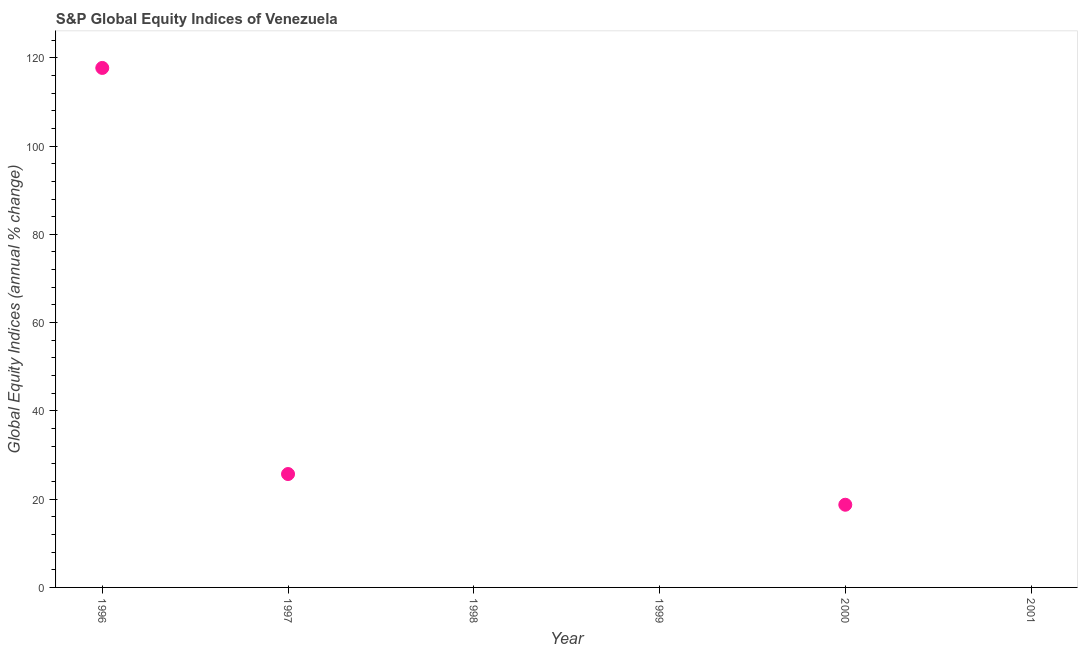Across all years, what is the maximum s&p global equity indices?
Your response must be concise. 117.7. Across all years, what is the minimum s&p global equity indices?
Make the answer very short. 0. What is the sum of the s&p global equity indices?
Give a very brief answer. 162.13. What is the difference between the s&p global equity indices in 1996 and 2000?
Give a very brief answer. 98.96. What is the average s&p global equity indices per year?
Offer a very short reply. 27.02. What is the median s&p global equity indices?
Give a very brief answer. 9.37. What is the ratio of the s&p global equity indices in 1997 to that in 2000?
Make the answer very short. 1.37. Is the difference between the s&p global equity indices in 1996 and 1997 greater than the difference between any two years?
Offer a terse response. No. What is the difference between the highest and the second highest s&p global equity indices?
Your response must be concise. 92.01. What is the difference between the highest and the lowest s&p global equity indices?
Offer a very short reply. 117.7. How many years are there in the graph?
Provide a short and direct response. 6. Does the graph contain any zero values?
Your answer should be compact. Yes. What is the title of the graph?
Provide a short and direct response. S&P Global Equity Indices of Venezuela. What is the label or title of the Y-axis?
Keep it short and to the point. Global Equity Indices (annual % change). What is the Global Equity Indices (annual % change) in 1996?
Keep it short and to the point. 117.7. What is the Global Equity Indices (annual % change) in 1997?
Make the answer very short. 25.69. What is the Global Equity Indices (annual % change) in 2000?
Keep it short and to the point. 18.74. What is the Global Equity Indices (annual % change) in 2001?
Your answer should be compact. 0. What is the difference between the Global Equity Indices (annual % change) in 1996 and 1997?
Make the answer very short. 92.01. What is the difference between the Global Equity Indices (annual % change) in 1996 and 2000?
Offer a very short reply. 98.96. What is the difference between the Global Equity Indices (annual % change) in 1997 and 2000?
Your answer should be very brief. 6.96. What is the ratio of the Global Equity Indices (annual % change) in 1996 to that in 1997?
Give a very brief answer. 4.58. What is the ratio of the Global Equity Indices (annual % change) in 1996 to that in 2000?
Provide a short and direct response. 6.28. What is the ratio of the Global Equity Indices (annual % change) in 1997 to that in 2000?
Offer a terse response. 1.37. 